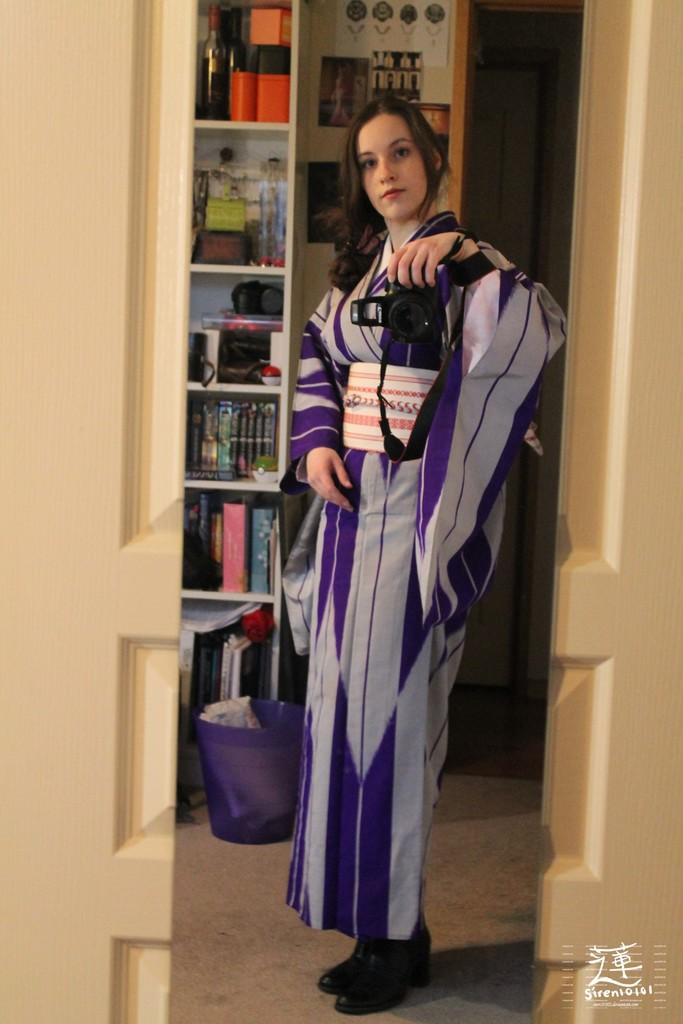Who is the main subject in the image? There is a lady in the image. What is the lady wearing? The lady is wearing a violet dress. What is the lady holding in her hands? The lady is holding a camera in her hands. What can be seen in the background of the image? There are books, a bottle, and a dustbin in the background of the image. What type of disease is the lady suffering from in the image? There is no indication of any disease in the image; the lady is simply holding a camera. Can you tell me where the sink is located in the image? There is no sink present in the image. 